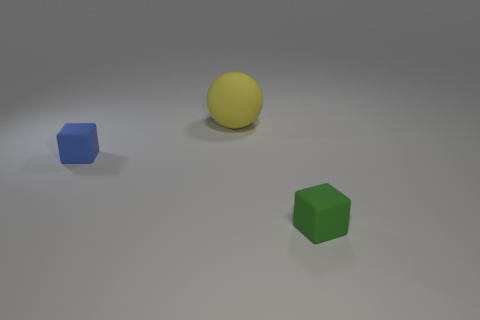Add 1 blocks. How many objects exist? 4 Subtract all blocks. How many objects are left? 1 Subtract all large matte objects. Subtract all tiny objects. How many objects are left? 0 Add 3 yellow objects. How many yellow objects are left? 4 Add 3 large rubber spheres. How many large rubber spheres exist? 4 Subtract 0 green cylinders. How many objects are left? 3 